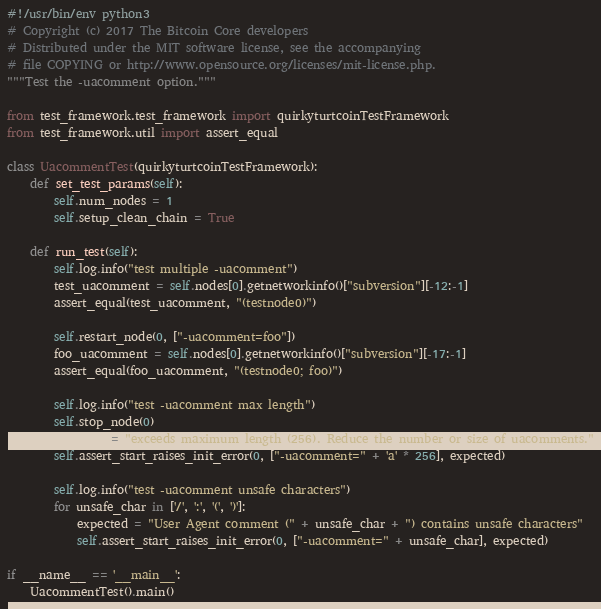Convert code to text. <code><loc_0><loc_0><loc_500><loc_500><_Python_>#!/usr/bin/env python3
# Copyright (c) 2017 The Bitcoin Core developers
# Distributed under the MIT software license, see the accompanying
# file COPYING or http://www.opensource.org/licenses/mit-license.php.
"""Test the -uacomment option."""

from test_framework.test_framework import quirkyturtcoinTestFramework
from test_framework.util import assert_equal

class UacommentTest(quirkyturtcoinTestFramework):
    def set_test_params(self):
        self.num_nodes = 1
        self.setup_clean_chain = True

    def run_test(self):
        self.log.info("test multiple -uacomment")
        test_uacomment = self.nodes[0].getnetworkinfo()["subversion"][-12:-1]
        assert_equal(test_uacomment, "(testnode0)")

        self.restart_node(0, ["-uacomment=foo"])
        foo_uacomment = self.nodes[0].getnetworkinfo()["subversion"][-17:-1]
        assert_equal(foo_uacomment, "(testnode0; foo)")

        self.log.info("test -uacomment max length")
        self.stop_node(0)
        expected = "exceeds maximum length (256). Reduce the number or size of uacomments."
        self.assert_start_raises_init_error(0, ["-uacomment=" + 'a' * 256], expected)

        self.log.info("test -uacomment unsafe characters")
        for unsafe_char in ['/', ':', '(', ')']:
            expected = "User Agent comment (" + unsafe_char + ") contains unsafe characters"
            self.assert_start_raises_init_error(0, ["-uacomment=" + unsafe_char], expected)

if __name__ == '__main__':
    UacommentTest().main()
</code> 